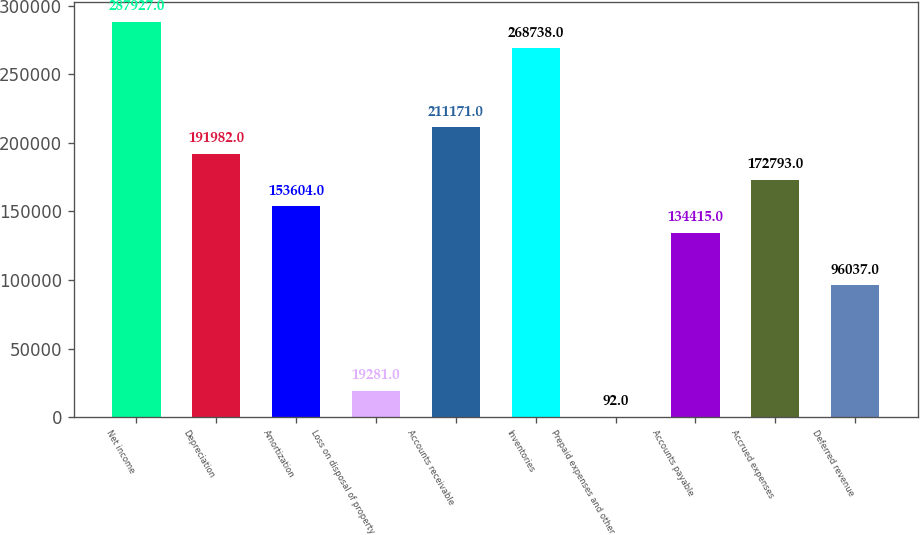Convert chart. <chart><loc_0><loc_0><loc_500><loc_500><bar_chart><fcel>Net income<fcel>Depreciation<fcel>Amortization<fcel>Loss on disposal of property<fcel>Accounts receivable<fcel>Inventories<fcel>Prepaid expenses and other<fcel>Accounts payable<fcel>Accrued expenses<fcel>Deferred revenue<nl><fcel>287927<fcel>191982<fcel>153604<fcel>19281<fcel>211171<fcel>268738<fcel>92<fcel>134415<fcel>172793<fcel>96037<nl></chart> 